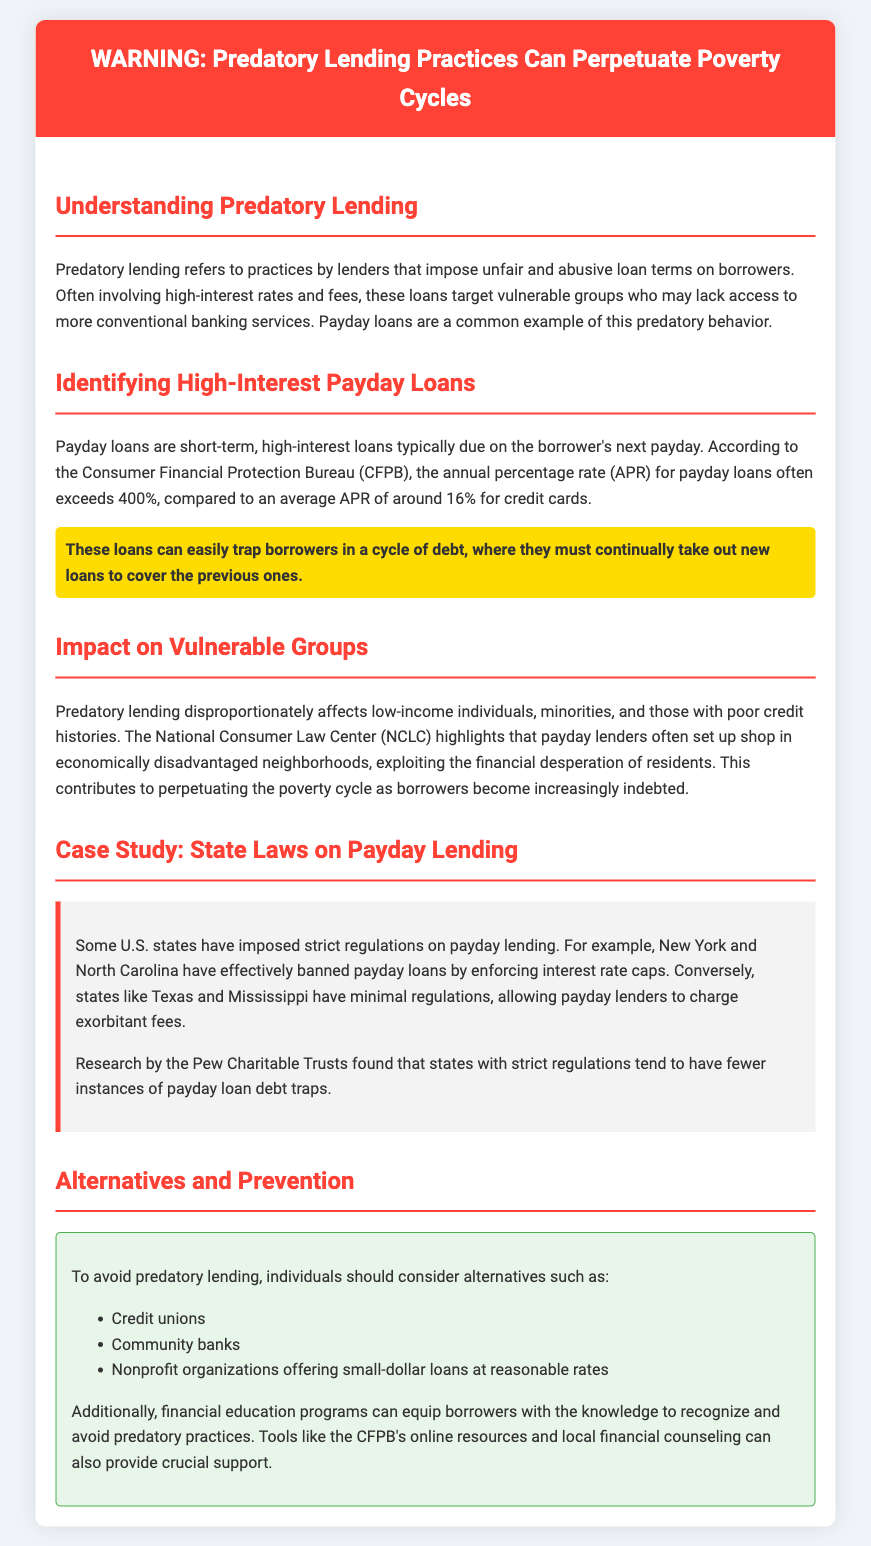What is predatory lending? Predatory lending refers to practices by lenders that impose unfair and abusive loan terms on borrowers.
Answer: Unfair and abusive loan terms What is the typical APR for payday loans? According to the Consumer Financial Protection Bureau (CFPB), the APR for payday loans often exceeds 400%.
Answer: Exceeds 400% Who is disproportionately affected by predatory lending? Predatory lending disproportionately affects low-income individuals, minorities, and those with poor credit histories.
Answer: Low-income individuals, minorities, and those with poor credit histories What states have effectively banned payday loans? New York and North Carolina have effectively banned payday loans by enforcing interest rate caps.
Answer: New York and North Carolina What is a recommended alternative to avoid predatory lending? Individuals should consider credit unions as an alternative to avoid predatory lending.
Answer: Credit unions What resource can help borrowers recognize predatory practices? Tools like the CFPB's online resources can provide crucial support to recognize and avoid predatory practices.
Answer: CFPB's online resources 